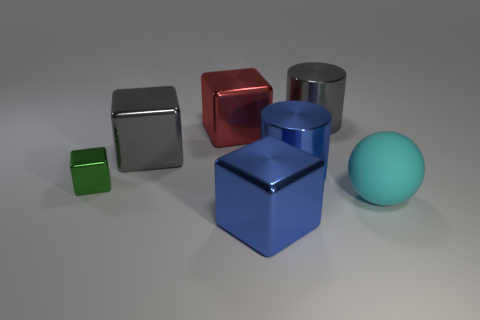There is a gray thing that is on the right side of the blue metal cylinder; is it the same shape as the cyan thing?
Make the answer very short. No. The big gray metal object to the left of the blue thing that is in front of the big cyan ball is what shape?
Give a very brief answer. Cube. There is a blue metallic object behind the blue object in front of the blue metallic thing behind the small shiny block; what size is it?
Keep it short and to the point. Large. What color is the other small metal object that is the same shape as the red object?
Your answer should be compact. Green. Do the gray cylinder and the green cube have the same size?
Provide a succinct answer. No. What material is the blue object in front of the blue cylinder?
Provide a succinct answer. Metal. What number of other things are the same shape as the small metallic object?
Your answer should be very brief. 3. Is the shape of the green thing the same as the large red object?
Keep it short and to the point. Yes. Are there any big red shiny things in front of the big cyan matte ball?
Your answer should be very brief. No. What number of things are either big blue cubes or small green shiny cubes?
Make the answer very short. 2. 